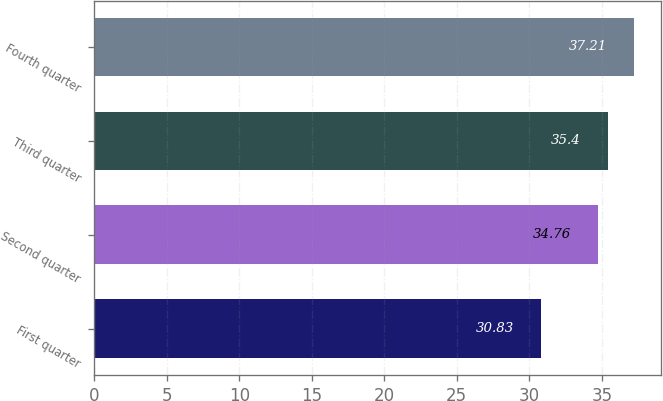<chart> <loc_0><loc_0><loc_500><loc_500><bar_chart><fcel>First quarter<fcel>Second quarter<fcel>Third quarter<fcel>Fourth quarter<nl><fcel>30.83<fcel>34.76<fcel>35.4<fcel>37.21<nl></chart> 